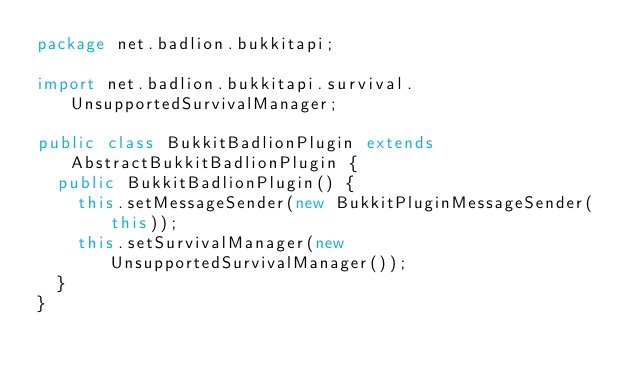Convert code to text. <code><loc_0><loc_0><loc_500><loc_500><_Java_>package net.badlion.bukkitapi;

import net.badlion.bukkitapi.survival.UnsupportedSurvivalManager;

public class BukkitBadlionPlugin extends AbstractBukkitBadlionPlugin {
	public BukkitBadlionPlugin() {
		this.setMessageSender(new BukkitPluginMessageSender(this));
		this.setSurvivalManager(new UnsupportedSurvivalManager());
	}
}</code> 